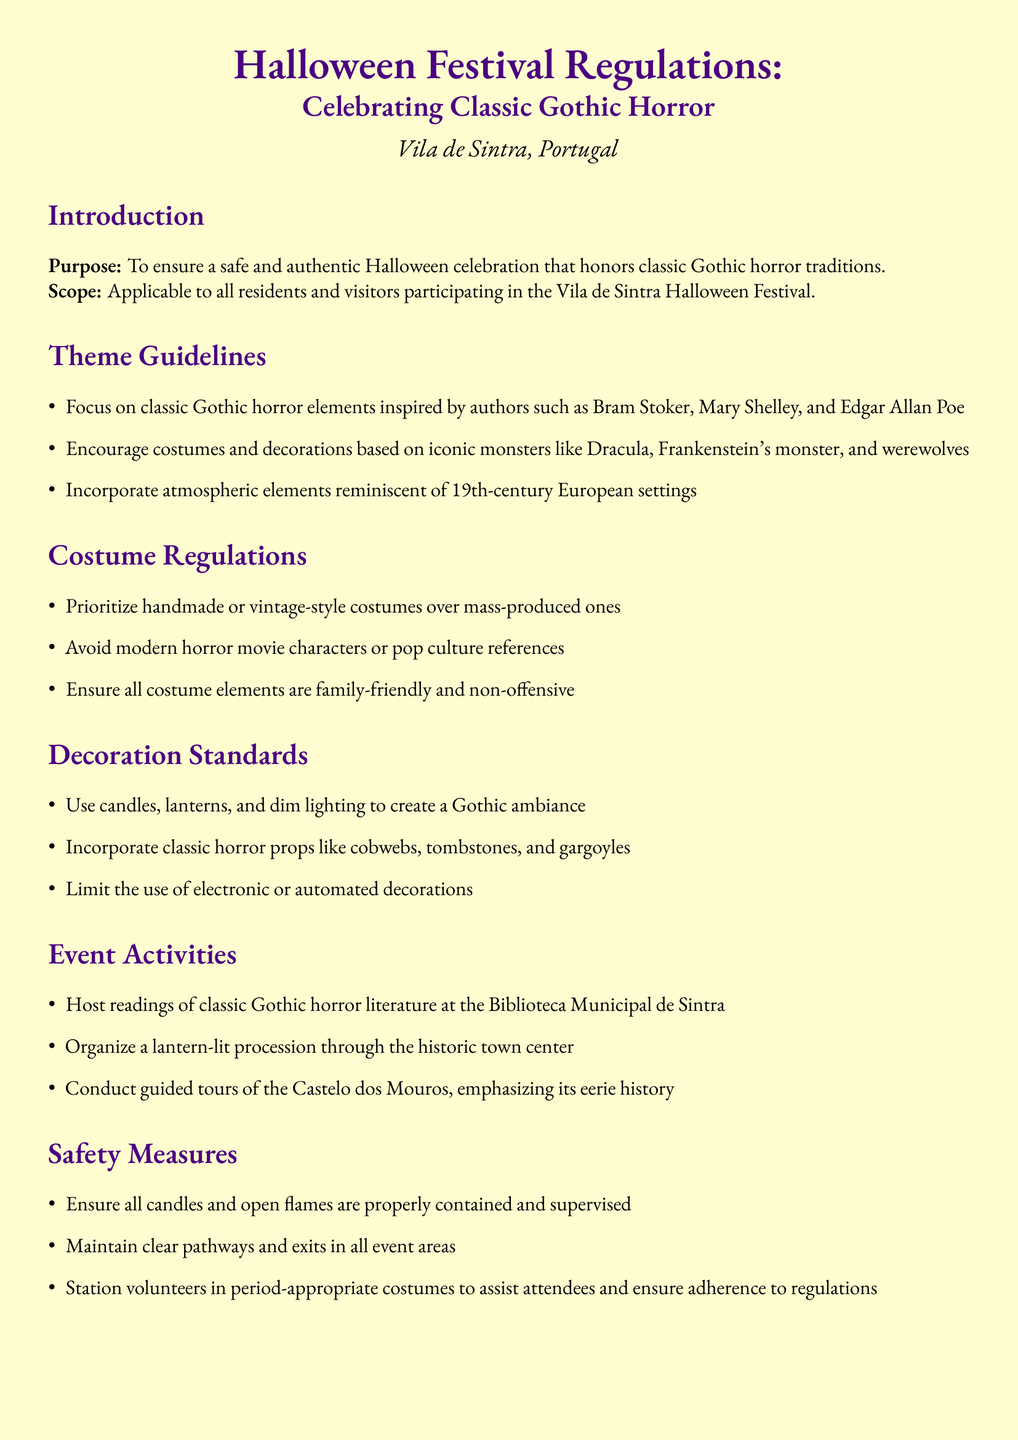What is the main purpose of the document? The purpose of the document is stated in the introduction, which is to ensure a safe and authentic Halloween celebration that honors classic Gothic horror traditions.
Answer: to ensure a safe and authentic Halloween celebration that honors classic Gothic horror traditions Who is responsible for enforcing the regulations? The responsible authority is specified in the enforcement policy section of the document, which states the Câmara Municipal de Sintra.
Answer: Câmara Municipal de Sintra Which authors inspire the theme guidelines? The theme guidelines mention specific authors that serve as inspiration, namely Bram Stoker, Mary Shelley, and Edgar Allan Poe.
Answer: Bram Stoker, Mary Shelley, and Edgar Allan Poe What type of costumes are prioritized according to the regulations? The costume regulations specify that handmade or vintage-style costumes are prioritized over mass-produced ones.
Answer: handmade or vintage-style costumes What types of activities are included in the event? The event activities section lists specific activities to be conducted, such as readings of classic Gothic horror literature at the Biblioteca Municipal de Sintra.
Answer: readings of classic Gothic horror literature at the Biblioteca Municipal de Sintra What is the consequence for non-compliant participants? The enforcement policy outlines consequences for non-compliance, stating that non-compliant participants may be asked to modify their costumes or decorations.
Answer: may be asked to modify their costumes or decorations What type of lighting is encouraged for decorations? The decoration standards specify the use of candles, lanterns, and dim lighting to create a Gothic ambiance.
Answer: candles, lanterns, and dim lighting How will safety be ensured regarding candles? The safety measures include a directive that ensures all candles and open flames are properly contained and supervised.
Answer: properly contained and supervised 